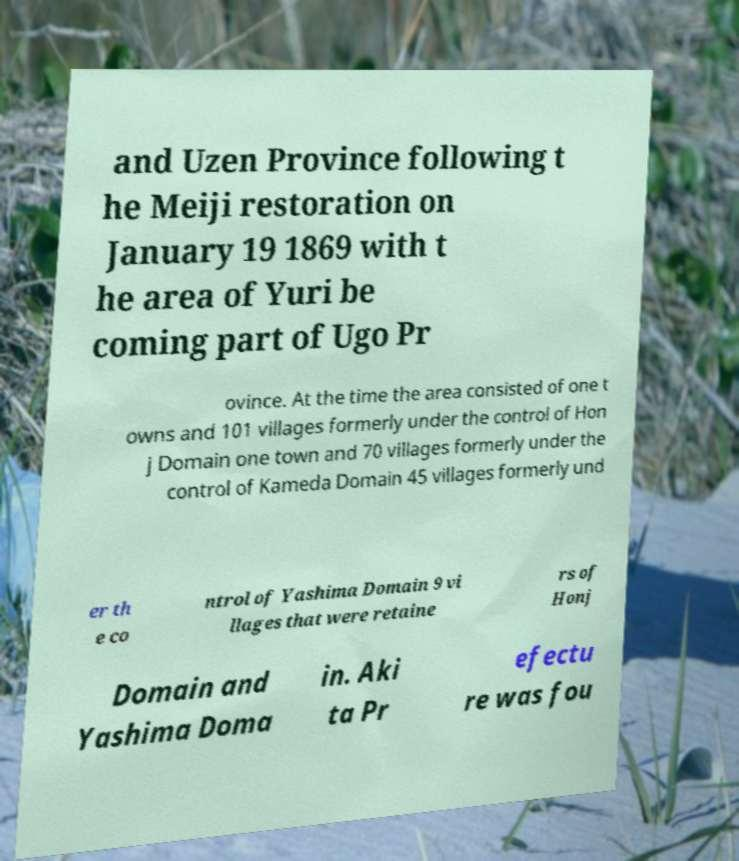Can you accurately transcribe the text from the provided image for me? and Uzen Province following t he Meiji restoration on January 19 1869 with t he area of Yuri be coming part of Ugo Pr ovince. At the time the area consisted of one t owns and 101 villages formerly under the control of Hon j Domain one town and 70 villages formerly under the control of Kameda Domain 45 villages formerly und er th e co ntrol of Yashima Domain 9 vi llages that were retaine rs of Honj Domain and Yashima Doma in. Aki ta Pr efectu re was fou 